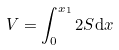<formula> <loc_0><loc_0><loc_500><loc_500>V = \int _ { 0 } ^ { x _ { 1 } } 2 S \mathrm d x</formula> 